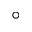<formula> <loc_0><loc_0><loc_500><loc_500>^ { \circ }</formula> 